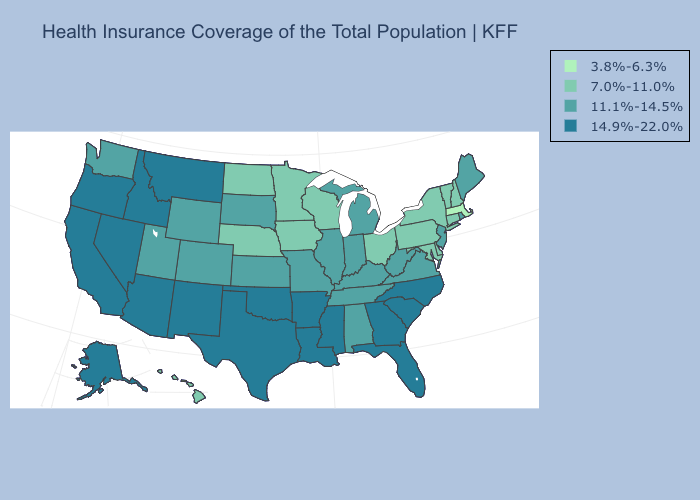Among the states that border Montana , does North Dakota have the lowest value?
Give a very brief answer. Yes. What is the highest value in the USA?
Short answer required. 14.9%-22.0%. Which states have the lowest value in the USA?
Concise answer only. Massachusetts. What is the highest value in states that border Alabama?
Be succinct. 14.9%-22.0%. What is the highest value in the MidWest ?
Short answer required. 11.1%-14.5%. What is the highest value in states that border Arkansas?
Be succinct. 14.9%-22.0%. Name the states that have a value in the range 14.9%-22.0%?
Be succinct. Alaska, Arizona, Arkansas, California, Florida, Georgia, Idaho, Louisiana, Mississippi, Montana, Nevada, New Mexico, North Carolina, Oklahoma, Oregon, South Carolina, Texas. Does the map have missing data?
Answer briefly. No. Name the states that have a value in the range 3.8%-6.3%?
Short answer required. Massachusetts. Does Massachusetts have the lowest value in the USA?
Write a very short answer. Yes. Name the states that have a value in the range 11.1%-14.5%?
Quick response, please. Alabama, Colorado, Illinois, Indiana, Kansas, Kentucky, Maine, Michigan, Missouri, New Jersey, Rhode Island, South Dakota, Tennessee, Utah, Virginia, Washington, West Virginia, Wyoming. How many symbols are there in the legend?
Quick response, please. 4. Name the states that have a value in the range 11.1%-14.5%?
Give a very brief answer. Alabama, Colorado, Illinois, Indiana, Kansas, Kentucky, Maine, Michigan, Missouri, New Jersey, Rhode Island, South Dakota, Tennessee, Utah, Virginia, Washington, West Virginia, Wyoming. Name the states that have a value in the range 11.1%-14.5%?
Answer briefly. Alabama, Colorado, Illinois, Indiana, Kansas, Kentucky, Maine, Michigan, Missouri, New Jersey, Rhode Island, South Dakota, Tennessee, Utah, Virginia, Washington, West Virginia, Wyoming. Does Georgia have the same value as Mississippi?
Write a very short answer. Yes. 